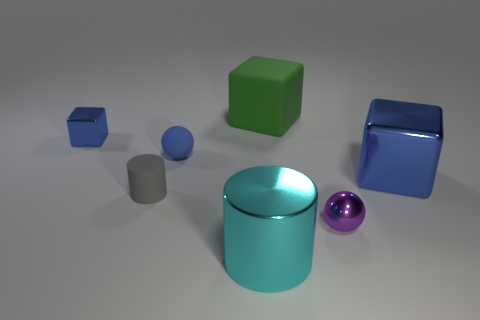Add 2 small rubber spheres. How many objects exist? 9 Subtract all cylinders. How many objects are left? 5 Subtract all tiny blocks. Subtract all large yellow blocks. How many objects are left? 6 Add 4 small matte spheres. How many small matte spheres are left? 5 Add 3 big cylinders. How many big cylinders exist? 4 Subtract 0 yellow cubes. How many objects are left? 7 